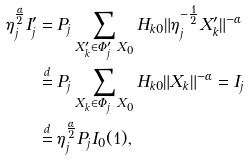<formula> <loc_0><loc_0><loc_500><loc_500>\eta _ { j } ^ { \frac { \alpha } { 2 } } I ^ { \prime } _ { j } & = P _ { j } \sum _ { X ^ { \prime } _ { k } \in \Phi ^ { \prime } _ { j } \ X _ { 0 } } H _ { k 0 } \| \eta _ { j } ^ { - \frac { 1 } { 2 } } X ^ { \prime } _ { k } \| ^ { - \alpha } \\ & \stackrel { d } { = } P _ { j } \sum _ { X _ { k } \in \Phi _ { j } \ X _ { 0 } } H _ { k 0 } \| X _ { k } \| ^ { - \alpha } = I _ { j } \\ & \stackrel { d } { = } \eta _ { j } ^ { \frac { \alpha } { 2 } } P _ { j } I _ { 0 } ( 1 ) ,</formula> 